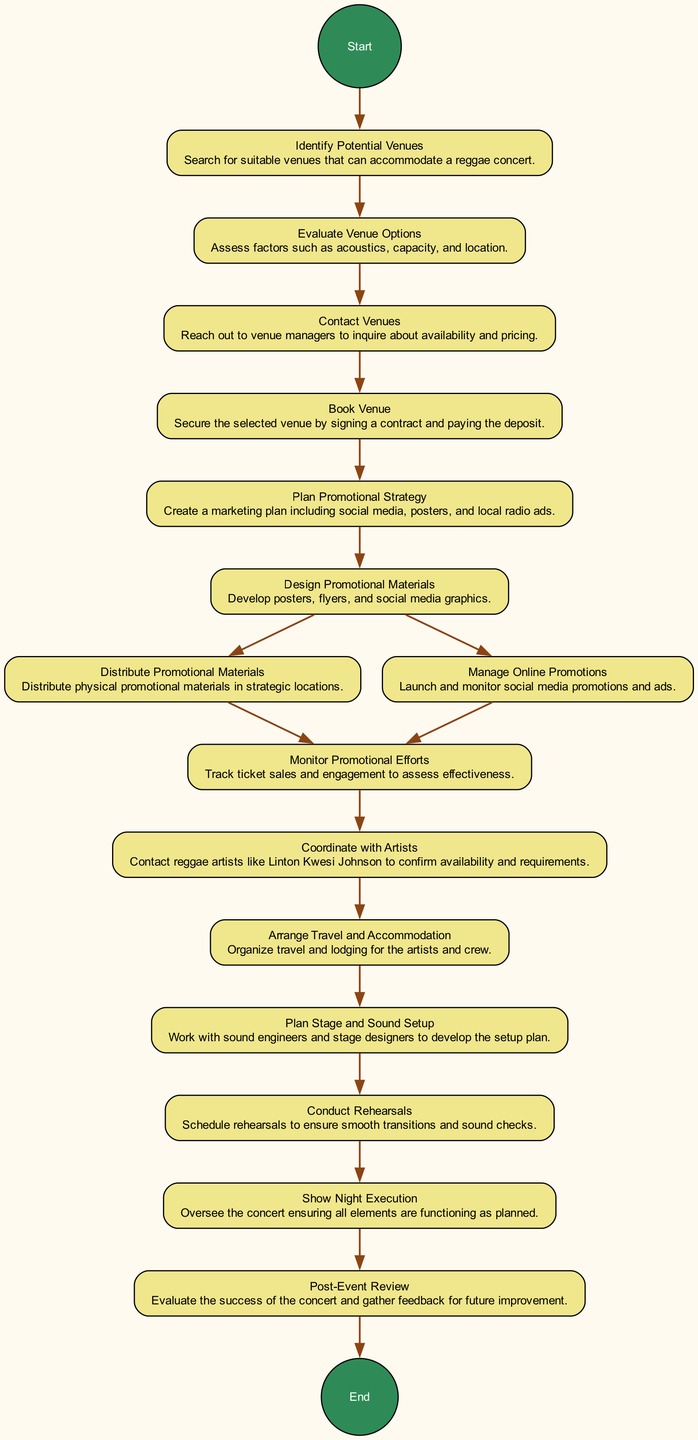What is the first activity in the diagram? The first activity listed is "Identify Potential Venues". There are no edges leading into this activity, indicating that it is the starting point of the process.
Answer: Identify Potential Venues How many activities are there in total? By counting each activity listed in the diagram, we find there are a total of 15 activities, starting from "Identify Potential Venues" to "Post-Event Review".
Answer: 15 What activity follows "Contact Venues"? The next activity after "Contact Venues" is "Book Venue". This is clearly indicated by the arrow leading from "Contact Venues" to "Book Venue".
Answer: Book Venue What is the last activity before execution on show night? The final activity before "Show Night Execution" is "Conduct Rehearsals". This can be traced through the flow leading to execution night.
Answer: Conduct Rehearsals Which activity involves artists like Linton Kwesi Johnson? The activity that mentions contacting artists such as Linton Kwesi Johnson is "Coordinate with Artists". This activity specifically outlines the action of confirming availability and requirements with artists.
Answer: Coordinate with Artists How many promotional strategies are planned before the concert? There are two activities focused on promotional strategies: "Plan Promotional Strategy" and "Design Promotional Materials". Both are essential parts of the promotional plan leading up to the concert.
Answer: 2 What is the role of the "Monitor Promotional Efforts" activity? The purpose of "Monitor Promotional Efforts" is to track ticket sales and engagement, which assesses the effectiveness of the promotional strategies that were executed prior to the concert.
Answer: Track ticket sales and engagement What are the two paths after "Design Promotional Materials"? After "Design Promotional Materials", there are two paths: "Distribute Promotional Materials" and "Manage Online Promotions". This shows that promotional efforts can take two different routes simultaneously.
Answer: Distribute Promotional Materials and Manage Online Promotions What activity forms the conclusion of the concert planning process? The last activity in the diagram is "Post-Event Review", which signifies the closing phase of the concert planning process, aimed at evaluating the concert's success and gathering feedback.
Answer: Post-Event Review 